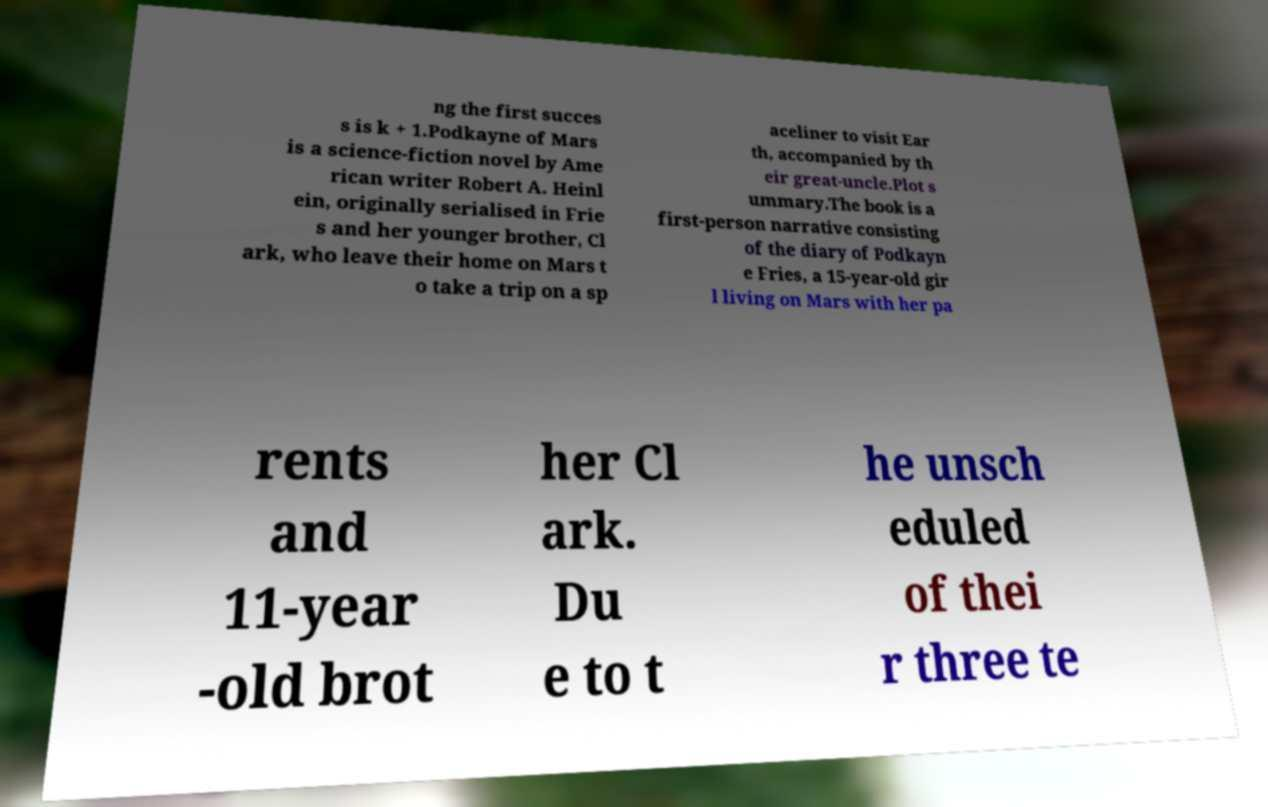Can you accurately transcribe the text from the provided image for me? ng the first succes s is k + 1.Podkayne of Mars is a science-fiction novel by Ame rican writer Robert A. Heinl ein, originally serialised in Frie s and her younger brother, Cl ark, who leave their home on Mars t o take a trip on a sp aceliner to visit Ear th, accompanied by th eir great-uncle.Plot s ummary.The book is a first-person narrative consisting of the diary of Podkayn e Fries, a 15-year-old gir l living on Mars with her pa rents and 11-year -old brot her Cl ark. Du e to t he unsch eduled of thei r three te 